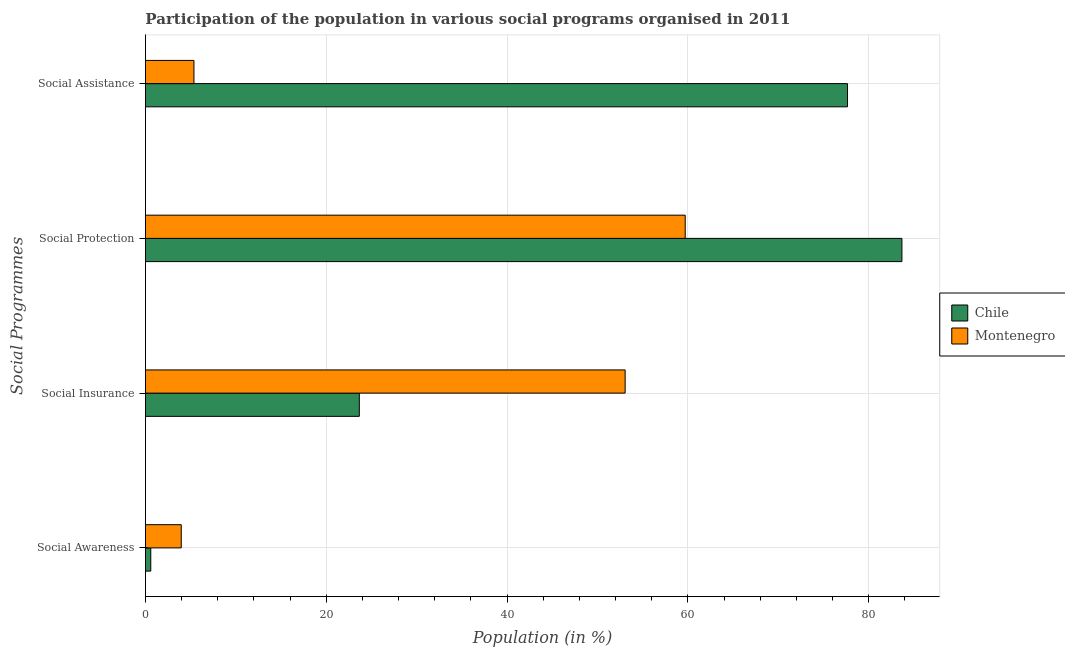Are the number of bars per tick equal to the number of legend labels?
Ensure brevity in your answer.  Yes. How many bars are there on the 2nd tick from the bottom?
Your answer should be compact. 2. What is the label of the 2nd group of bars from the top?
Offer a very short reply. Social Protection. What is the participation of population in social assistance programs in Chile?
Provide a succinct answer. 77.66. Across all countries, what is the maximum participation of population in social insurance programs?
Make the answer very short. 53.06. Across all countries, what is the minimum participation of population in social awareness programs?
Keep it short and to the point. 0.59. In which country was the participation of population in social protection programs maximum?
Provide a short and direct response. Chile. In which country was the participation of population in social assistance programs minimum?
Provide a succinct answer. Montenegro. What is the total participation of population in social awareness programs in the graph?
Provide a short and direct response. 4.55. What is the difference between the participation of population in social protection programs in Chile and that in Montenegro?
Your response must be concise. 23.97. What is the difference between the participation of population in social assistance programs in Montenegro and the participation of population in social insurance programs in Chile?
Keep it short and to the point. -18.29. What is the average participation of population in social awareness programs per country?
Your response must be concise. 2.27. What is the difference between the participation of population in social awareness programs and participation of population in social assistance programs in Montenegro?
Keep it short and to the point. -1.41. In how many countries, is the participation of population in social insurance programs greater than 44 %?
Offer a terse response. 1. What is the ratio of the participation of population in social awareness programs in Montenegro to that in Chile?
Offer a very short reply. 6.71. Is the participation of population in social awareness programs in Chile less than that in Montenegro?
Your response must be concise. Yes. What is the difference between the highest and the second highest participation of population in social awareness programs?
Ensure brevity in your answer.  3.37. What is the difference between the highest and the lowest participation of population in social assistance programs?
Provide a succinct answer. 72.3. Is it the case that in every country, the sum of the participation of population in social assistance programs and participation of population in social awareness programs is greater than the sum of participation of population in social protection programs and participation of population in social insurance programs?
Your answer should be compact. Yes. What does the 1st bar from the top in Social Awareness represents?
Give a very brief answer. Montenegro. What does the 1st bar from the bottom in Social Assistance represents?
Ensure brevity in your answer.  Chile. How many countries are there in the graph?
Keep it short and to the point. 2. What is the difference between two consecutive major ticks on the X-axis?
Your answer should be compact. 20. Does the graph contain any zero values?
Give a very brief answer. No. Does the graph contain grids?
Offer a very short reply. Yes. How many legend labels are there?
Give a very brief answer. 2. What is the title of the graph?
Keep it short and to the point. Participation of the population in various social programs organised in 2011. Does "Honduras" appear as one of the legend labels in the graph?
Provide a short and direct response. No. What is the label or title of the X-axis?
Provide a short and direct response. Population (in %). What is the label or title of the Y-axis?
Give a very brief answer. Social Programmes. What is the Population (in %) in Chile in Social Awareness?
Provide a succinct answer. 0.59. What is the Population (in %) in Montenegro in Social Awareness?
Your response must be concise. 3.96. What is the Population (in %) of Chile in Social Insurance?
Ensure brevity in your answer.  23.66. What is the Population (in %) in Montenegro in Social Insurance?
Provide a short and direct response. 53.06. What is the Population (in %) in Chile in Social Protection?
Provide a succinct answer. 83.68. What is the Population (in %) of Montenegro in Social Protection?
Your answer should be very brief. 59.71. What is the Population (in %) in Chile in Social Assistance?
Provide a succinct answer. 77.66. What is the Population (in %) of Montenegro in Social Assistance?
Your answer should be very brief. 5.37. Across all Social Programmes, what is the maximum Population (in %) of Chile?
Offer a terse response. 83.68. Across all Social Programmes, what is the maximum Population (in %) of Montenegro?
Your response must be concise. 59.71. Across all Social Programmes, what is the minimum Population (in %) in Chile?
Keep it short and to the point. 0.59. Across all Social Programmes, what is the minimum Population (in %) in Montenegro?
Offer a terse response. 3.96. What is the total Population (in %) in Chile in the graph?
Your answer should be very brief. 185.59. What is the total Population (in %) of Montenegro in the graph?
Provide a succinct answer. 122.1. What is the difference between the Population (in %) of Chile in Social Awareness and that in Social Insurance?
Your answer should be compact. -23.07. What is the difference between the Population (in %) of Montenegro in Social Awareness and that in Social Insurance?
Your answer should be very brief. -49.1. What is the difference between the Population (in %) in Chile in Social Awareness and that in Social Protection?
Your answer should be compact. -83.09. What is the difference between the Population (in %) of Montenegro in Social Awareness and that in Social Protection?
Give a very brief answer. -55.75. What is the difference between the Population (in %) of Chile in Social Awareness and that in Social Assistance?
Make the answer very short. -77.07. What is the difference between the Population (in %) of Montenegro in Social Awareness and that in Social Assistance?
Your response must be concise. -1.41. What is the difference between the Population (in %) in Chile in Social Insurance and that in Social Protection?
Provide a succinct answer. -60.02. What is the difference between the Population (in %) of Montenegro in Social Insurance and that in Social Protection?
Your response must be concise. -6.65. What is the difference between the Population (in %) of Chile in Social Insurance and that in Social Assistance?
Make the answer very short. -54. What is the difference between the Population (in %) in Montenegro in Social Insurance and that in Social Assistance?
Keep it short and to the point. 47.7. What is the difference between the Population (in %) in Chile in Social Protection and that in Social Assistance?
Your answer should be compact. 6.02. What is the difference between the Population (in %) of Montenegro in Social Protection and that in Social Assistance?
Your answer should be compact. 54.34. What is the difference between the Population (in %) in Chile in Social Awareness and the Population (in %) in Montenegro in Social Insurance?
Offer a very short reply. -52.47. What is the difference between the Population (in %) of Chile in Social Awareness and the Population (in %) of Montenegro in Social Protection?
Make the answer very short. -59.12. What is the difference between the Population (in %) of Chile in Social Awareness and the Population (in %) of Montenegro in Social Assistance?
Your response must be concise. -4.78. What is the difference between the Population (in %) of Chile in Social Insurance and the Population (in %) of Montenegro in Social Protection?
Give a very brief answer. -36.05. What is the difference between the Population (in %) of Chile in Social Insurance and the Population (in %) of Montenegro in Social Assistance?
Offer a very short reply. 18.29. What is the difference between the Population (in %) of Chile in Social Protection and the Population (in %) of Montenegro in Social Assistance?
Give a very brief answer. 78.31. What is the average Population (in %) of Chile per Social Programmes?
Give a very brief answer. 46.4. What is the average Population (in %) of Montenegro per Social Programmes?
Offer a very short reply. 30.52. What is the difference between the Population (in %) of Chile and Population (in %) of Montenegro in Social Awareness?
Make the answer very short. -3.37. What is the difference between the Population (in %) in Chile and Population (in %) in Montenegro in Social Insurance?
Your response must be concise. -29.41. What is the difference between the Population (in %) of Chile and Population (in %) of Montenegro in Social Protection?
Your answer should be very brief. 23.97. What is the difference between the Population (in %) in Chile and Population (in %) in Montenegro in Social Assistance?
Your response must be concise. 72.3. What is the ratio of the Population (in %) in Chile in Social Awareness to that in Social Insurance?
Your answer should be very brief. 0.02. What is the ratio of the Population (in %) of Montenegro in Social Awareness to that in Social Insurance?
Make the answer very short. 0.07. What is the ratio of the Population (in %) in Chile in Social Awareness to that in Social Protection?
Offer a very short reply. 0.01. What is the ratio of the Population (in %) in Montenegro in Social Awareness to that in Social Protection?
Keep it short and to the point. 0.07. What is the ratio of the Population (in %) in Chile in Social Awareness to that in Social Assistance?
Your answer should be very brief. 0.01. What is the ratio of the Population (in %) of Montenegro in Social Awareness to that in Social Assistance?
Your response must be concise. 0.74. What is the ratio of the Population (in %) of Chile in Social Insurance to that in Social Protection?
Offer a terse response. 0.28. What is the ratio of the Population (in %) in Montenegro in Social Insurance to that in Social Protection?
Your answer should be very brief. 0.89. What is the ratio of the Population (in %) in Chile in Social Insurance to that in Social Assistance?
Your answer should be very brief. 0.3. What is the ratio of the Population (in %) of Montenegro in Social Insurance to that in Social Assistance?
Ensure brevity in your answer.  9.89. What is the ratio of the Population (in %) of Chile in Social Protection to that in Social Assistance?
Your response must be concise. 1.08. What is the ratio of the Population (in %) of Montenegro in Social Protection to that in Social Assistance?
Your response must be concise. 11.13. What is the difference between the highest and the second highest Population (in %) of Chile?
Your response must be concise. 6.02. What is the difference between the highest and the second highest Population (in %) in Montenegro?
Offer a very short reply. 6.65. What is the difference between the highest and the lowest Population (in %) in Chile?
Your answer should be very brief. 83.09. What is the difference between the highest and the lowest Population (in %) in Montenegro?
Offer a very short reply. 55.75. 